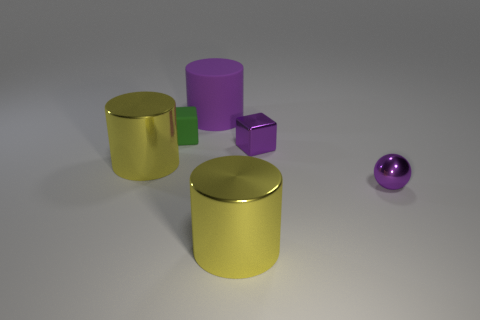Add 2 purple cylinders. How many objects exist? 8 Subtract all cubes. How many objects are left? 4 Subtract all tiny purple blocks. Subtract all yellow metal cylinders. How many objects are left? 3 Add 1 small things. How many small things are left? 4 Add 2 tiny shiny things. How many tiny shiny things exist? 4 Subtract 0 blue cylinders. How many objects are left? 6 